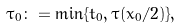<formula> <loc_0><loc_0><loc_500><loc_500>\tau _ { 0 } \colon = \min \{ t _ { 0 } , \tau ( x _ { 0 } / 2 ) \} ,</formula> 